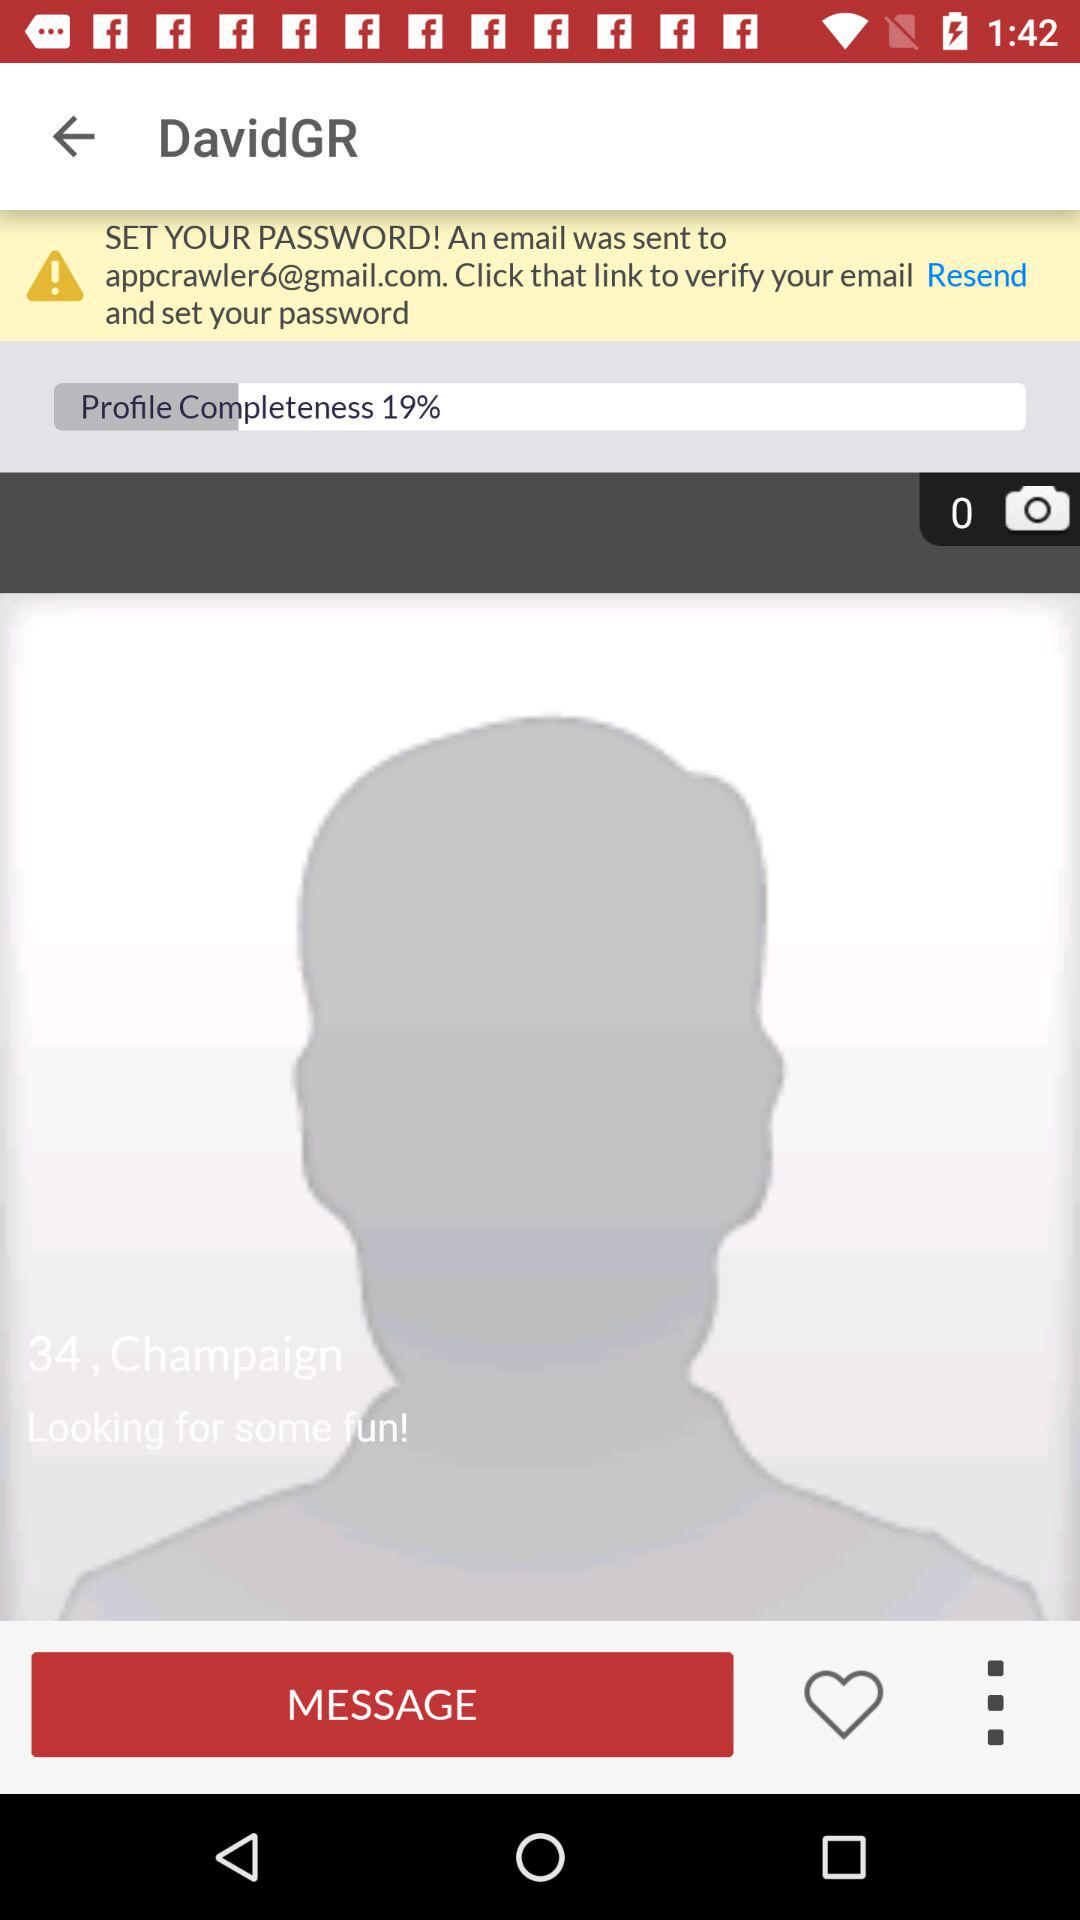What is the color selected?
When the provided information is insufficient, respond with <no answer>. <no answer> 